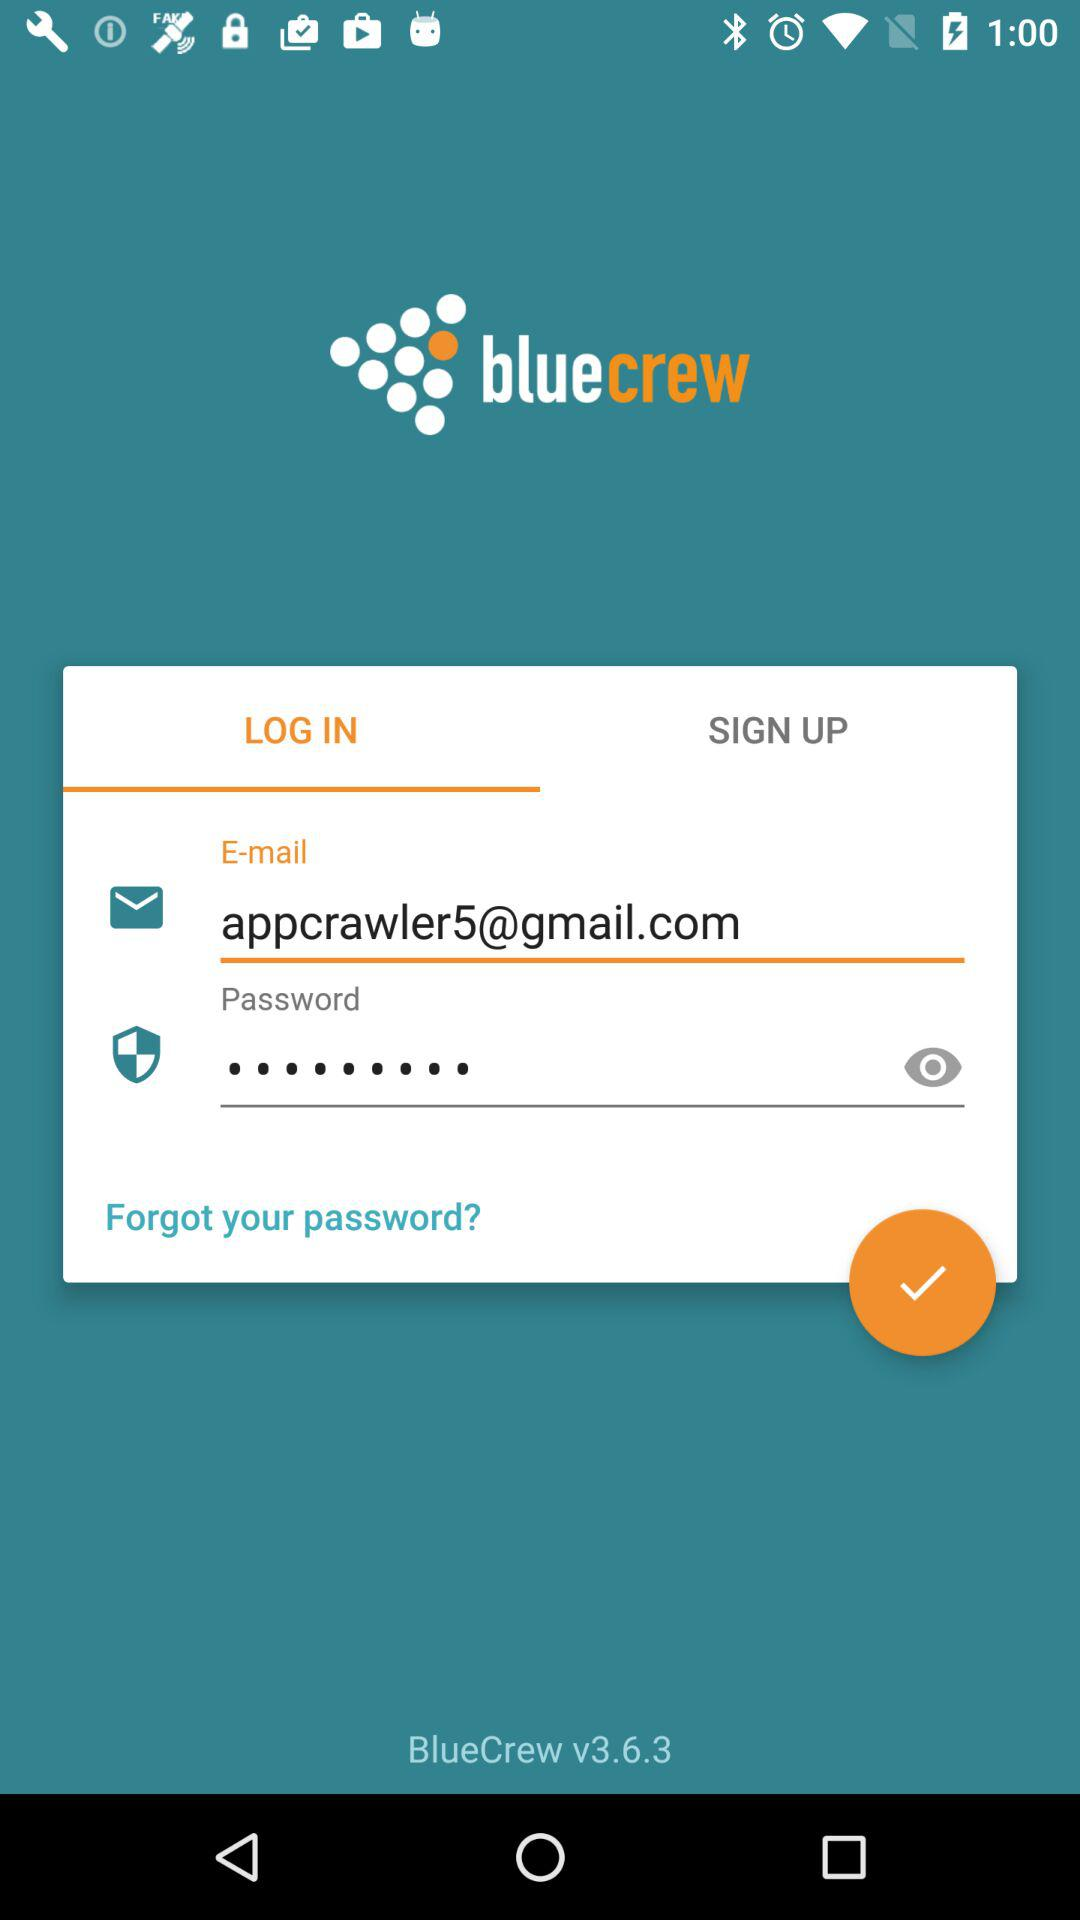What is the version of the application? The version is 3.6.3. 